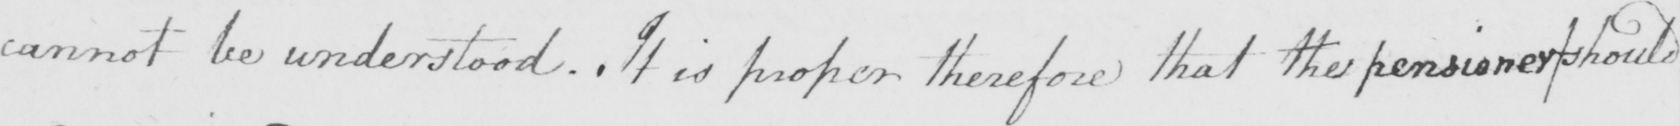What text is written in this handwritten line? cannot be understood . It is proper therefore that the pensioner should 